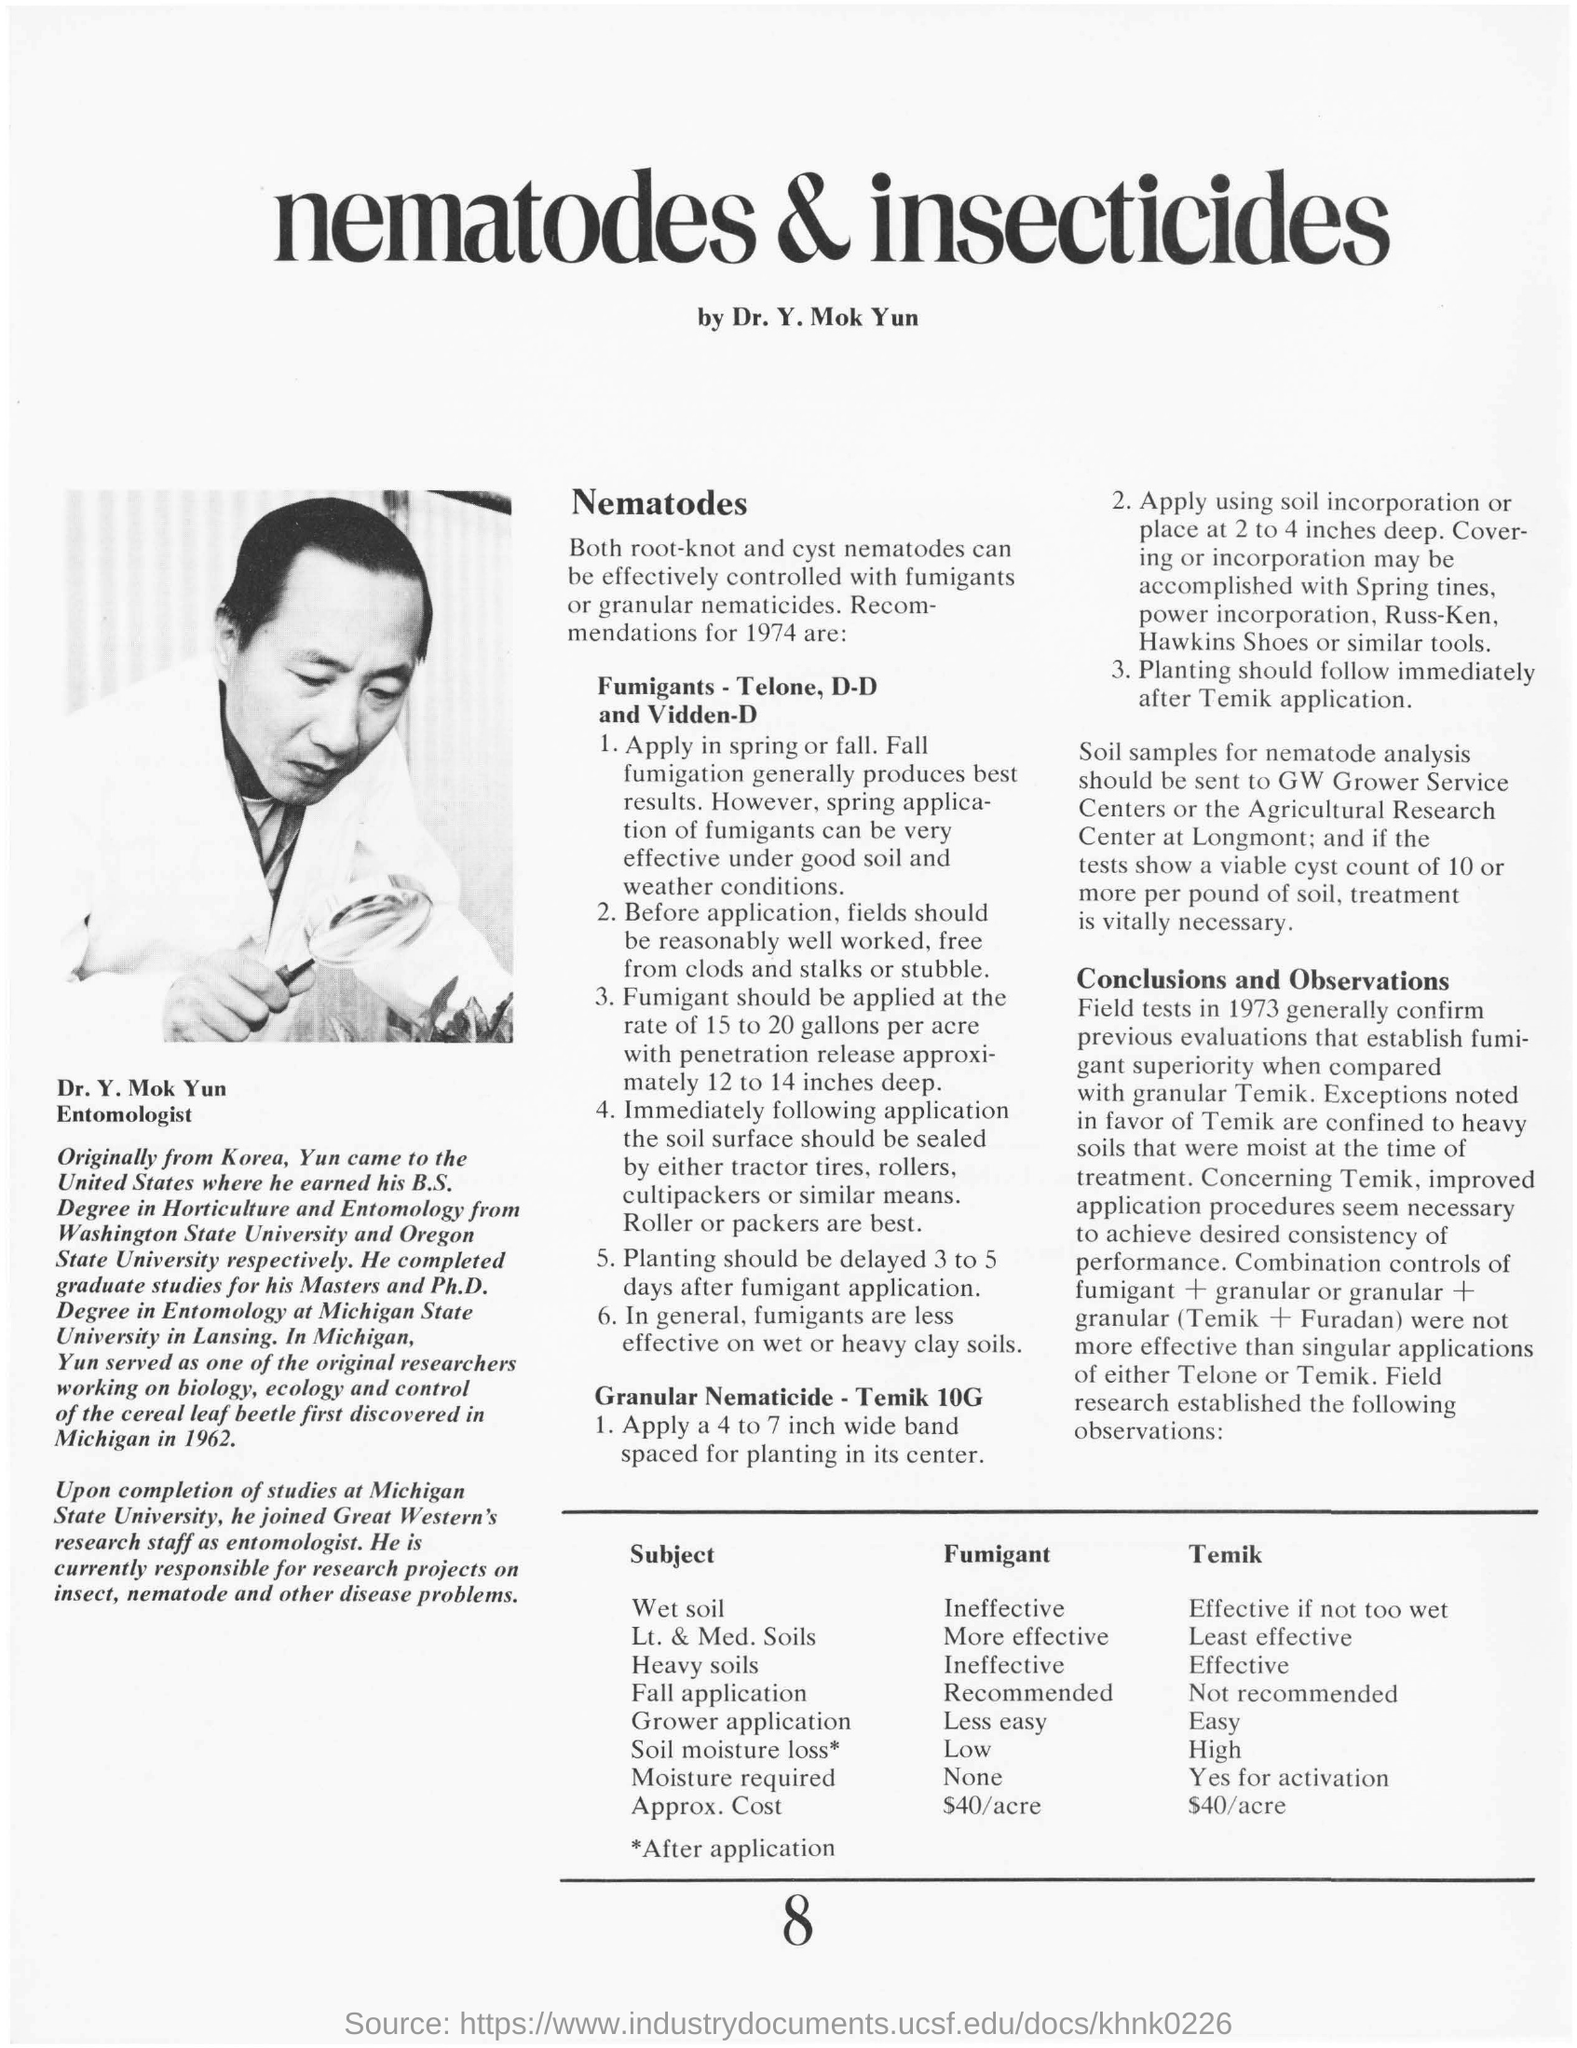Specify some key components in this picture. The application of fumigants in the spring is highly effective under favorable soil and weather conditions. The soil samples are sent for nematode analysis to either GW Grower Service Centers or the Agricultural Research Centre at Longmont. Fumigants are less effective in wet or heavy clay soils due to the soil's poor aeration and water repellence, which hinders the movement of the fumigant into the soil and its ability to kill soil-dwelling pests. The cost of the penetration release for a fumigant application at a depth of 12 to 14 inches is... Approximately 15 to 20 gallons of fumigant are applied to each acre. 